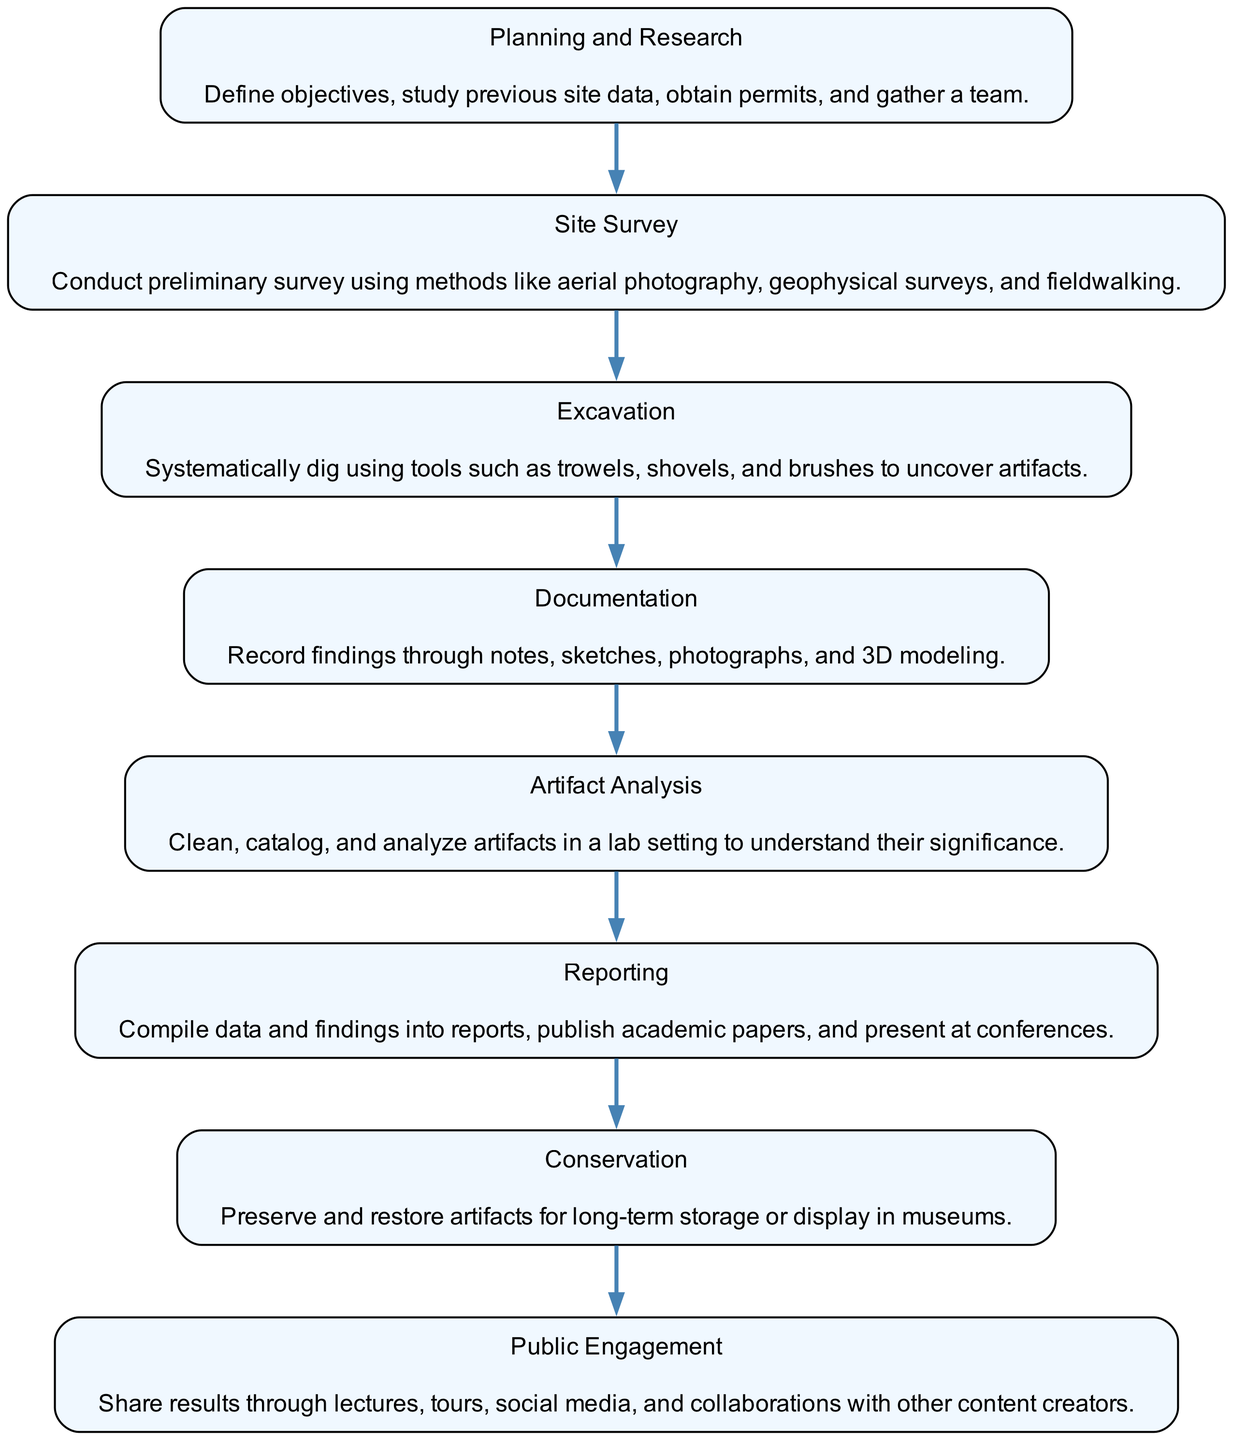What is the first step in the archaeological dig process? The flow chart indicates that the first step is "Planning and Research," where objectives are defined and permits are obtained.
Answer: Planning and Research How many nodes are present in the diagram? By counting the elements listed in the flow chart, there are a total of eight distinct nodes representing different steps in the archaeological dig process.
Answer: 8 What is the last step of the archaeological dig process? The last step indicated in the flow chart is "Public Engagement," which involves sharing results with the public and collaborating with other content creators.
Answer: Public Engagement What tool is primarily used during excavation? In the excavation step of the diagram, the tools mentioned include trowels, shovels, and brushes, with trowels being particularly common for detailing.
Answer: Trowels What connects the "Excavation" step to the next step? The diagram shows that "Excavation" leads directly to "Documentation," indicating that documentation follows the excavation process.
Answer: Documentation Which step follows "Artifact Analysis"? According to the diagram's sequence, "Artifact Analysis" is immediately followed by "Reporting," as sharing findings is essential after analyzing artifacts.
Answer: Reporting Explain the significance of the "Conservation" step in the process. The "Conservation" step comes after "Reporting" and is tasked with the preservation and restoration of artifacts, ensuring they are maintained for future study or display.
Answer: Preservation and restoration What is the primary purpose of "Public Engagement"? The purpose of "Public Engagement," the last step in the flow chart, is to share research findings through various platforms, enhancing community involvement and knowledge dissemination.
Answer: Share results How does "Documentation" support the process of archaeology? "Documentation" captures the findings from excavation through notes, sketches, and photographs, providing a vital record for future analysis and understanding of the site.
Answer: Record findings 